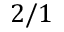<formula> <loc_0><loc_0><loc_500><loc_500>2 / 1</formula> 